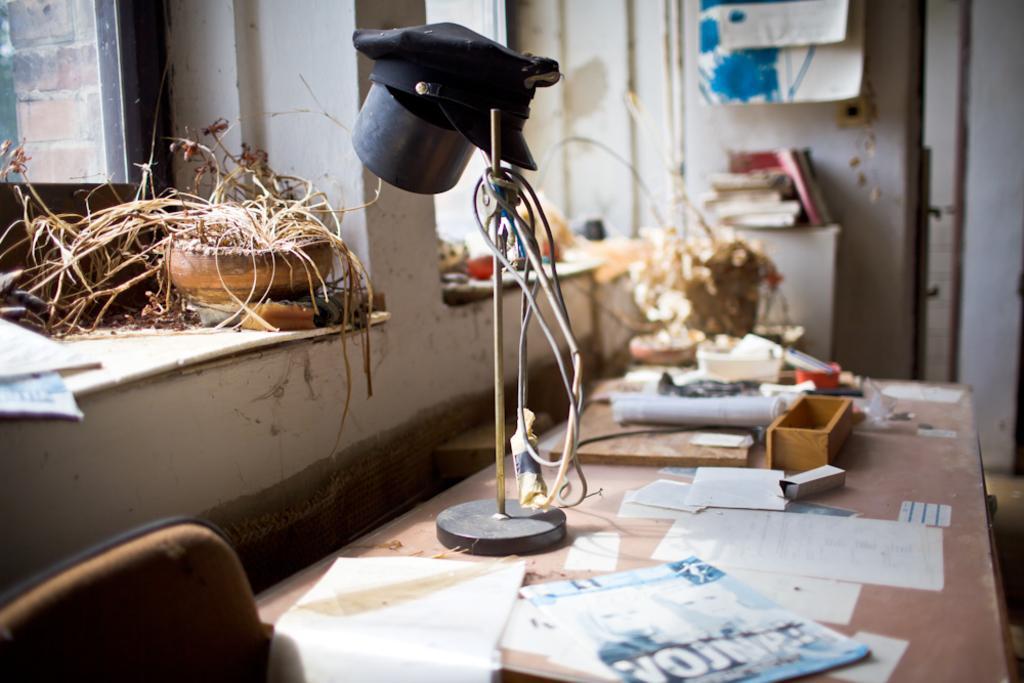Describe this image in one or two sentences. This image consists of a table on which there are papers and books along with a light. To the left, there are windows and there are potted plants. In the background, there is a wall. 